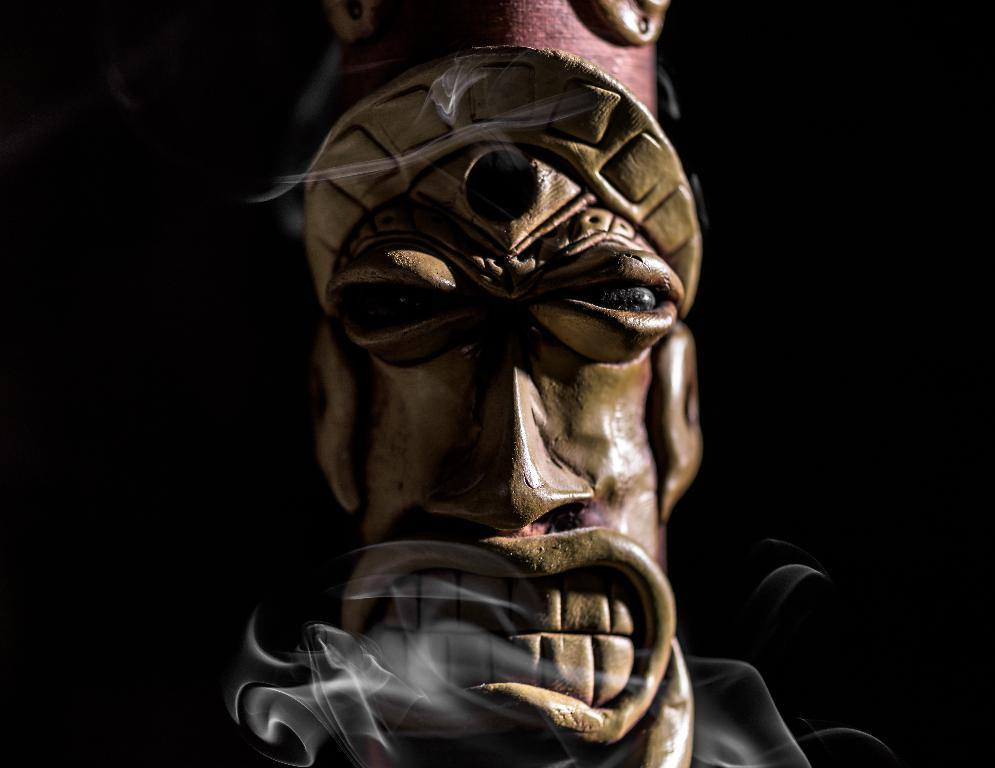What is the main subject of the picture? There is a demon statue in the picture. What can be observed about the background of the image? The background of the image appears to be black in color. Can you describe the environment in which the picture might have been taken? The picture might have been taken in a dark environment. What type of yam is being used to decorate the demon statue in the image? There is no yam present in the image, and the demon statue is not being decorated with any yam. 